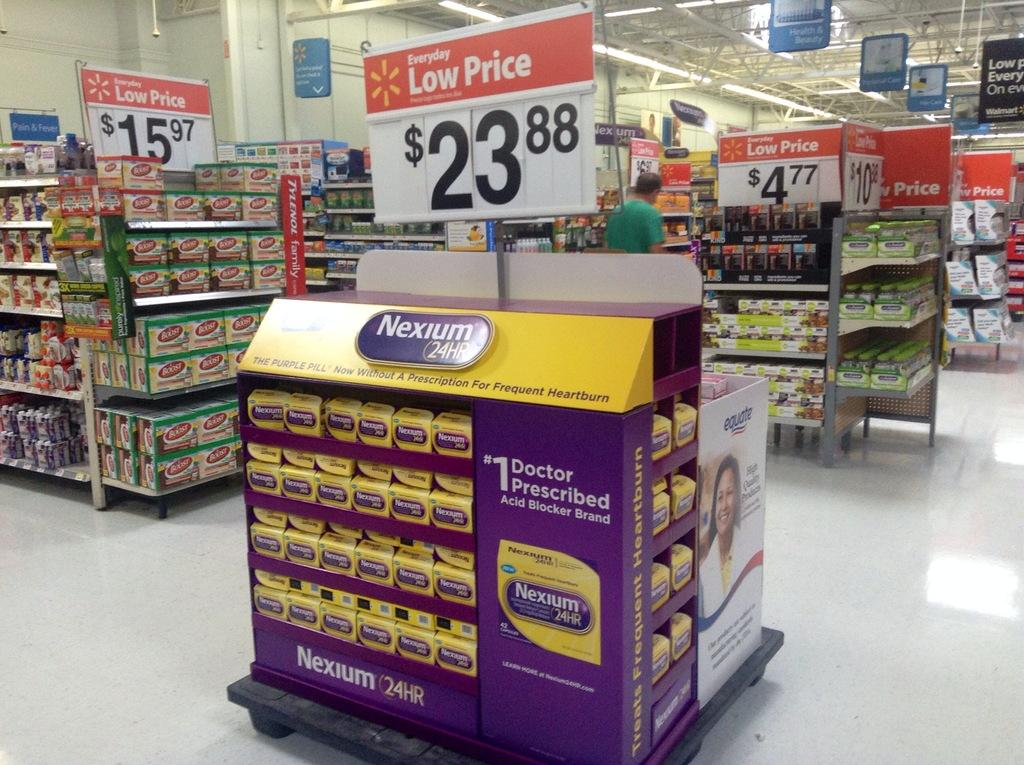<image>
Relay a brief, clear account of the picture shown. A center kiosk display that is a low price of 23.88 